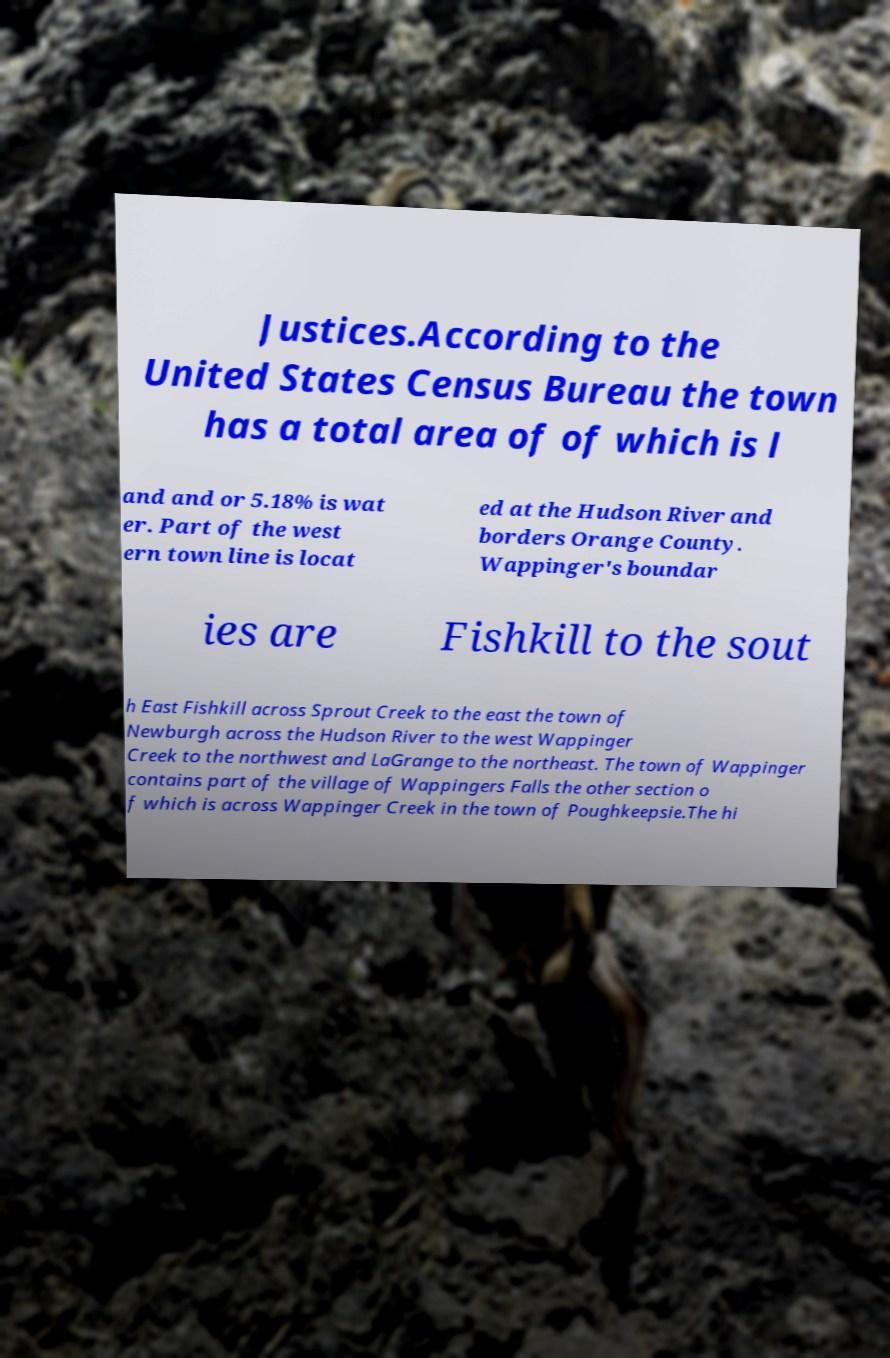What messages or text are displayed in this image? I need them in a readable, typed format. Justices.According to the United States Census Bureau the town has a total area of of which is l and and or 5.18% is wat er. Part of the west ern town line is locat ed at the Hudson River and borders Orange County. Wappinger's boundar ies are Fishkill to the sout h East Fishkill across Sprout Creek to the east the town of Newburgh across the Hudson River to the west Wappinger Creek to the northwest and LaGrange to the northeast. The town of Wappinger contains part of the village of Wappingers Falls the other section o f which is across Wappinger Creek in the town of Poughkeepsie.The hi 